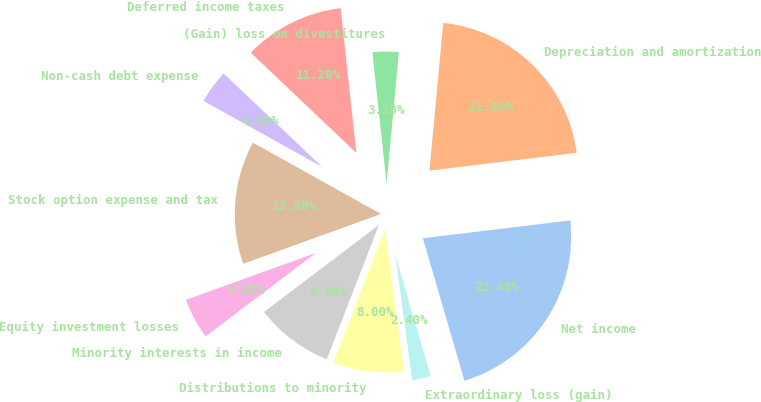<chart> <loc_0><loc_0><loc_500><loc_500><pie_chart><fcel>Net income<fcel>Depreciation and amortization<fcel>(Gain) loss on divestitures<fcel>Deferred income taxes<fcel>Non-cash debt expense<fcel>Stock option expense and tax<fcel>Equity investment losses<fcel>Minority interests in income<fcel>Distributions to minority<fcel>Extraordinary loss (gain)<nl><fcel>22.4%<fcel>21.6%<fcel>3.2%<fcel>11.2%<fcel>4.0%<fcel>13.6%<fcel>4.8%<fcel>8.8%<fcel>8.0%<fcel>2.4%<nl></chart> 